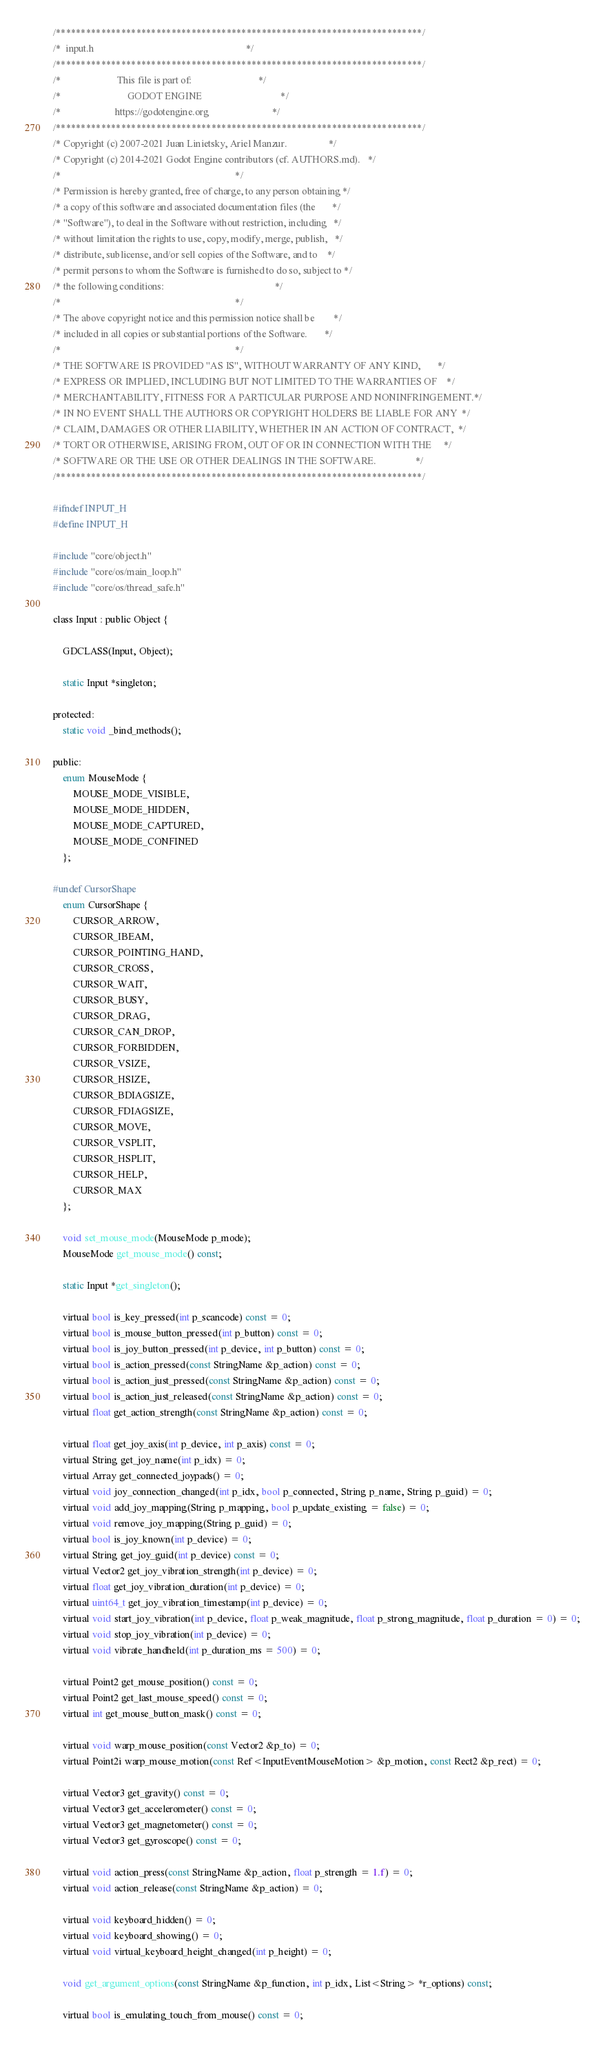Convert code to text. <code><loc_0><loc_0><loc_500><loc_500><_C_>/*************************************************************************/
/*  input.h                                                              */
/*************************************************************************/
/*                       This file is part of:                           */
/*                           GODOT ENGINE                                */
/*                      https://godotengine.org                          */
/*************************************************************************/
/* Copyright (c) 2007-2021 Juan Linietsky, Ariel Manzur.                 */
/* Copyright (c) 2014-2021 Godot Engine contributors (cf. AUTHORS.md).   */
/*                                                                       */
/* Permission is hereby granted, free of charge, to any person obtaining */
/* a copy of this software and associated documentation files (the       */
/* "Software"), to deal in the Software without restriction, including   */
/* without limitation the rights to use, copy, modify, merge, publish,   */
/* distribute, sublicense, and/or sell copies of the Software, and to    */
/* permit persons to whom the Software is furnished to do so, subject to */
/* the following conditions:                                             */
/*                                                                       */
/* The above copyright notice and this permission notice shall be        */
/* included in all copies or substantial portions of the Software.       */
/*                                                                       */
/* THE SOFTWARE IS PROVIDED "AS IS", WITHOUT WARRANTY OF ANY KIND,       */
/* EXPRESS OR IMPLIED, INCLUDING BUT NOT LIMITED TO THE WARRANTIES OF    */
/* MERCHANTABILITY, FITNESS FOR A PARTICULAR PURPOSE AND NONINFRINGEMENT.*/
/* IN NO EVENT SHALL THE AUTHORS OR COPYRIGHT HOLDERS BE LIABLE FOR ANY  */
/* CLAIM, DAMAGES OR OTHER LIABILITY, WHETHER IN AN ACTION OF CONTRACT,  */
/* TORT OR OTHERWISE, ARISING FROM, OUT OF OR IN CONNECTION WITH THE     */
/* SOFTWARE OR THE USE OR OTHER DEALINGS IN THE SOFTWARE.                */
/*************************************************************************/

#ifndef INPUT_H
#define INPUT_H

#include "core/object.h"
#include "core/os/main_loop.h"
#include "core/os/thread_safe.h"

class Input : public Object {

	GDCLASS(Input, Object);

	static Input *singleton;

protected:
	static void _bind_methods();

public:
	enum MouseMode {
		MOUSE_MODE_VISIBLE,
		MOUSE_MODE_HIDDEN,
		MOUSE_MODE_CAPTURED,
		MOUSE_MODE_CONFINED
	};

#undef CursorShape
	enum CursorShape {
		CURSOR_ARROW,
		CURSOR_IBEAM,
		CURSOR_POINTING_HAND,
		CURSOR_CROSS,
		CURSOR_WAIT,
		CURSOR_BUSY,
		CURSOR_DRAG,
		CURSOR_CAN_DROP,
		CURSOR_FORBIDDEN,
		CURSOR_VSIZE,
		CURSOR_HSIZE,
		CURSOR_BDIAGSIZE,
		CURSOR_FDIAGSIZE,
		CURSOR_MOVE,
		CURSOR_VSPLIT,
		CURSOR_HSPLIT,
		CURSOR_HELP,
		CURSOR_MAX
	};

	void set_mouse_mode(MouseMode p_mode);
	MouseMode get_mouse_mode() const;

	static Input *get_singleton();

	virtual bool is_key_pressed(int p_scancode) const = 0;
	virtual bool is_mouse_button_pressed(int p_button) const = 0;
	virtual bool is_joy_button_pressed(int p_device, int p_button) const = 0;
	virtual bool is_action_pressed(const StringName &p_action) const = 0;
	virtual bool is_action_just_pressed(const StringName &p_action) const = 0;
	virtual bool is_action_just_released(const StringName &p_action) const = 0;
	virtual float get_action_strength(const StringName &p_action) const = 0;

	virtual float get_joy_axis(int p_device, int p_axis) const = 0;
	virtual String get_joy_name(int p_idx) = 0;
	virtual Array get_connected_joypads() = 0;
	virtual void joy_connection_changed(int p_idx, bool p_connected, String p_name, String p_guid) = 0;
	virtual void add_joy_mapping(String p_mapping, bool p_update_existing = false) = 0;
	virtual void remove_joy_mapping(String p_guid) = 0;
	virtual bool is_joy_known(int p_device) = 0;
	virtual String get_joy_guid(int p_device) const = 0;
	virtual Vector2 get_joy_vibration_strength(int p_device) = 0;
	virtual float get_joy_vibration_duration(int p_device) = 0;
	virtual uint64_t get_joy_vibration_timestamp(int p_device) = 0;
	virtual void start_joy_vibration(int p_device, float p_weak_magnitude, float p_strong_magnitude, float p_duration = 0) = 0;
	virtual void stop_joy_vibration(int p_device) = 0;
	virtual void vibrate_handheld(int p_duration_ms = 500) = 0;

	virtual Point2 get_mouse_position() const = 0;
	virtual Point2 get_last_mouse_speed() const = 0;
	virtual int get_mouse_button_mask() const = 0;

	virtual void warp_mouse_position(const Vector2 &p_to) = 0;
	virtual Point2i warp_mouse_motion(const Ref<InputEventMouseMotion> &p_motion, const Rect2 &p_rect) = 0;

	virtual Vector3 get_gravity() const = 0;
	virtual Vector3 get_accelerometer() const = 0;
	virtual Vector3 get_magnetometer() const = 0;
	virtual Vector3 get_gyroscope() const = 0;

	virtual void action_press(const StringName &p_action, float p_strength = 1.f) = 0;
	virtual void action_release(const StringName &p_action) = 0;

	virtual void keyboard_hidden() = 0;
	virtual void keyboard_showing() = 0;
	virtual void virtual_keyboard_height_changed(int p_height) = 0;
	
	void get_argument_options(const StringName &p_function, int p_idx, List<String> *r_options) const;

	virtual bool is_emulating_touch_from_mouse() const = 0;</code> 